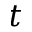Convert formula to latex. <formula><loc_0><loc_0><loc_500><loc_500>t</formula> 